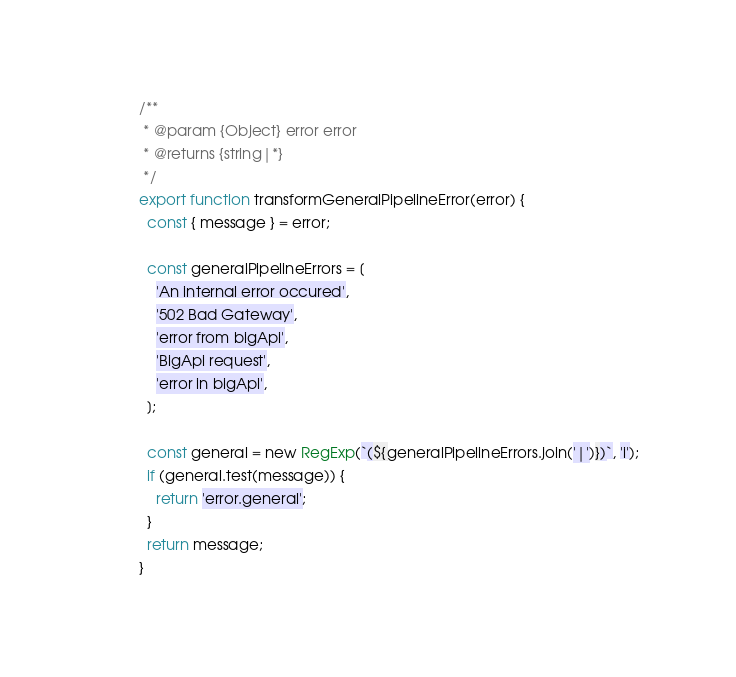Convert code to text. <code><loc_0><loc_0><loc_500><loc_500><_JavaScript_>/**
 * @param {Object} error error
 * @returns {string|*}
 */
export function transformGeneralPipelineError(error) {
  const { message } = error;

  const generalPipelineErrors = [
    'An internal error occured',
    '502 Bad Gateway',
    'error from bigApi',
    'BigApi request',
    'error in bigApi',
  ];

  const general = new RegExp(`(${generalPipelineErrors.join('|')})`, 'i');
  if (general.test(message)) {
    return 'error.general';
  }
  return message;
}
</code> 